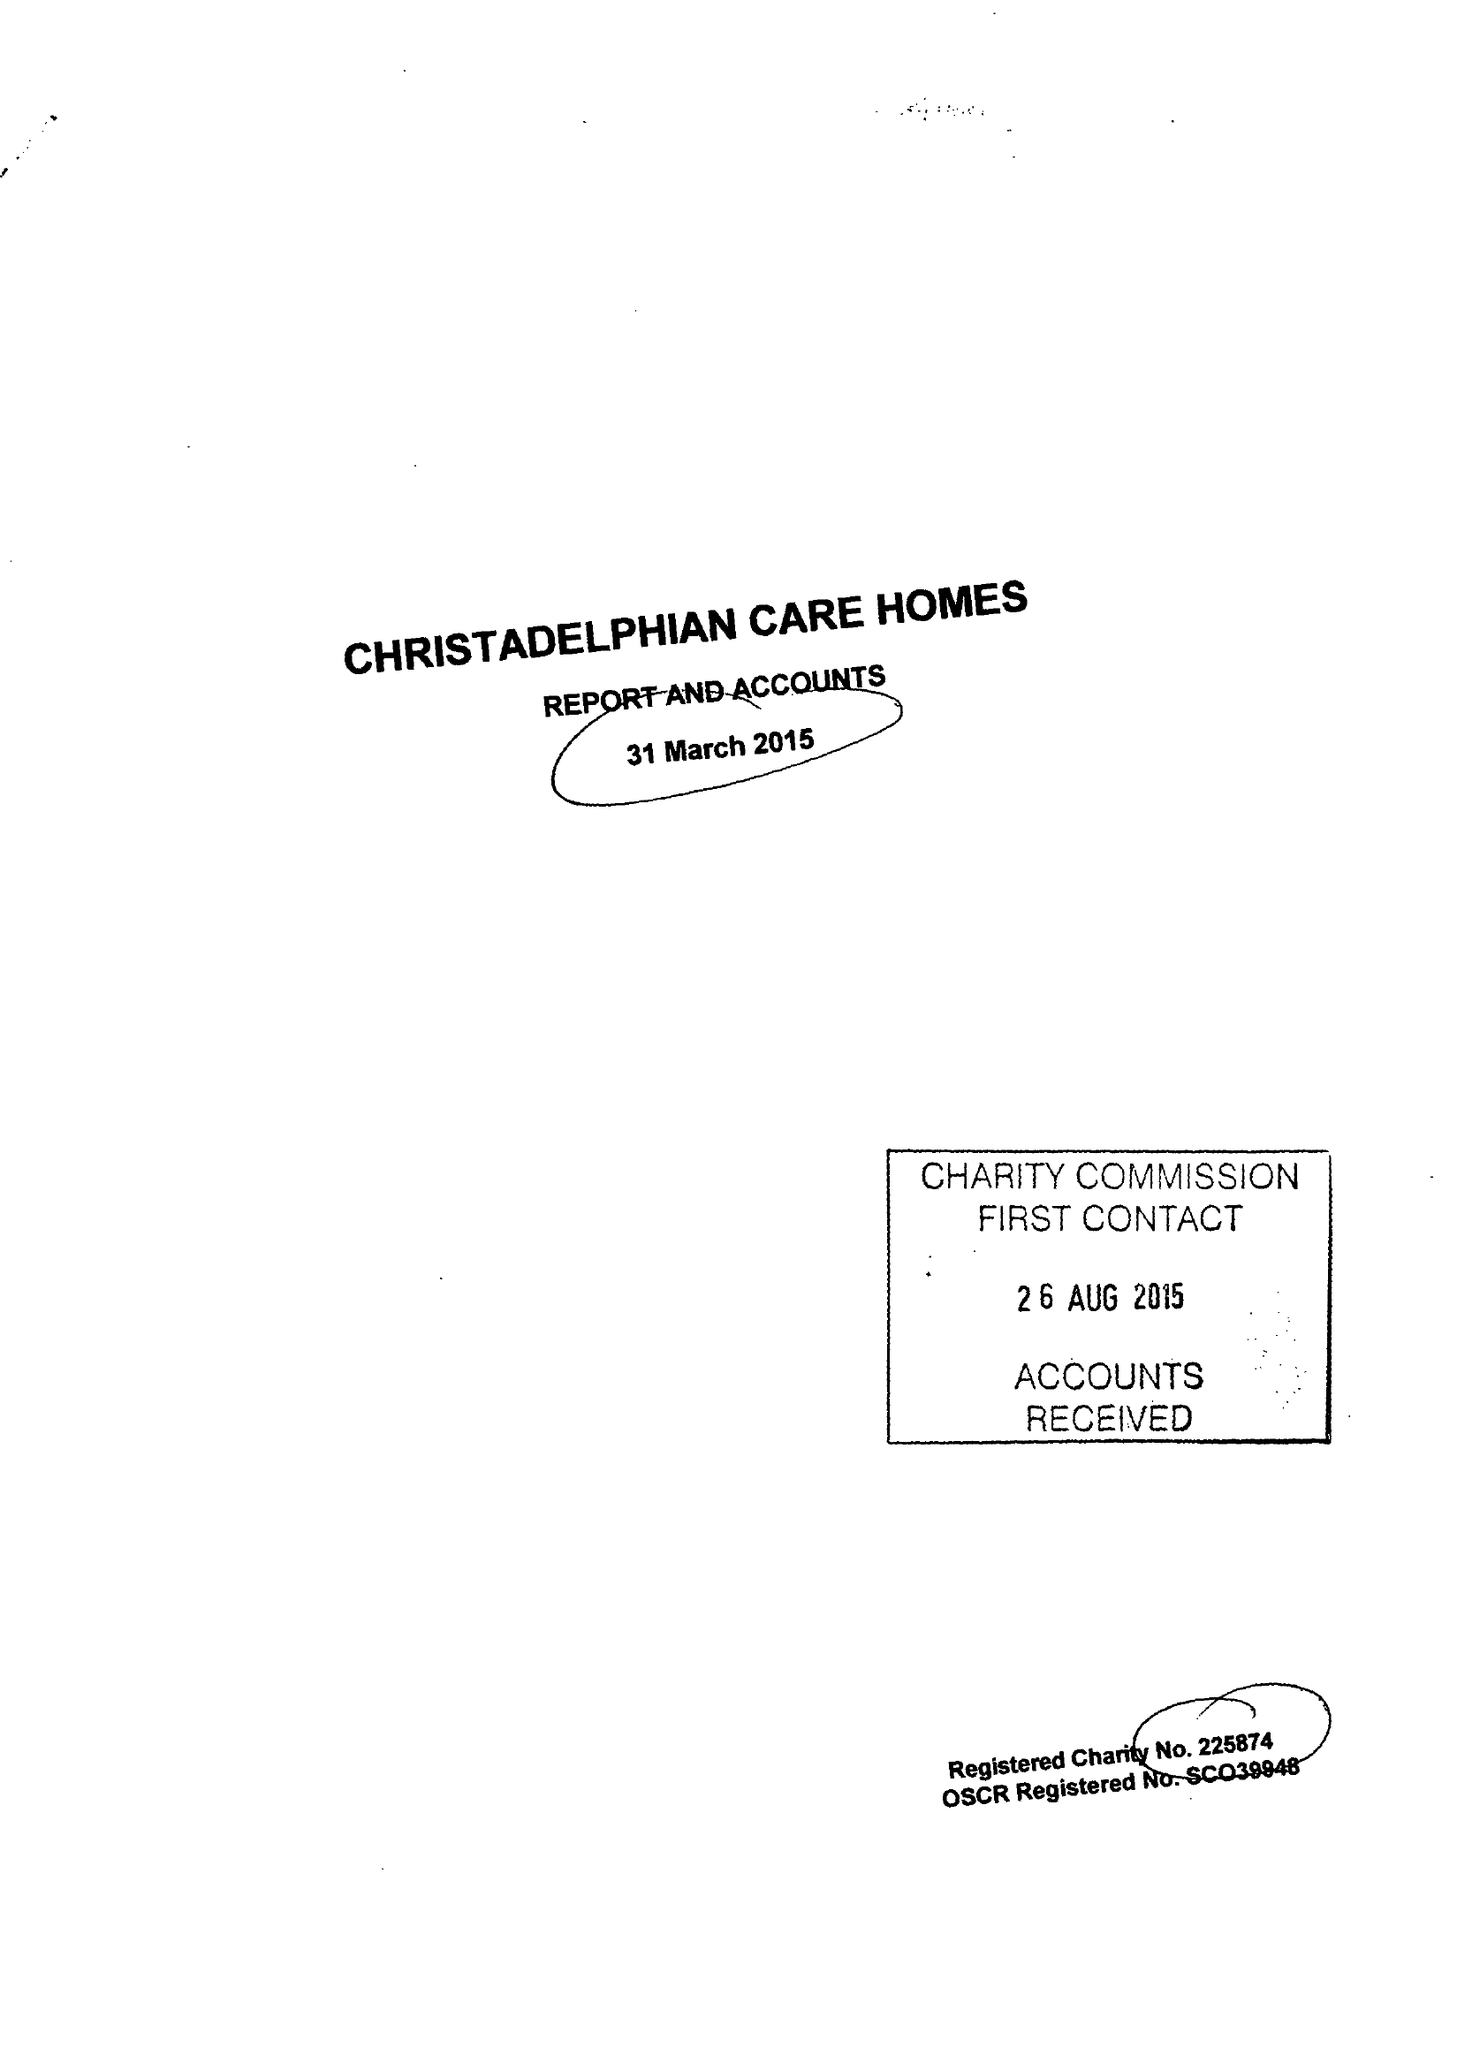What is the value for the address__post_town?
Answer the question using a single word or phrase. BIRMINGHAM 